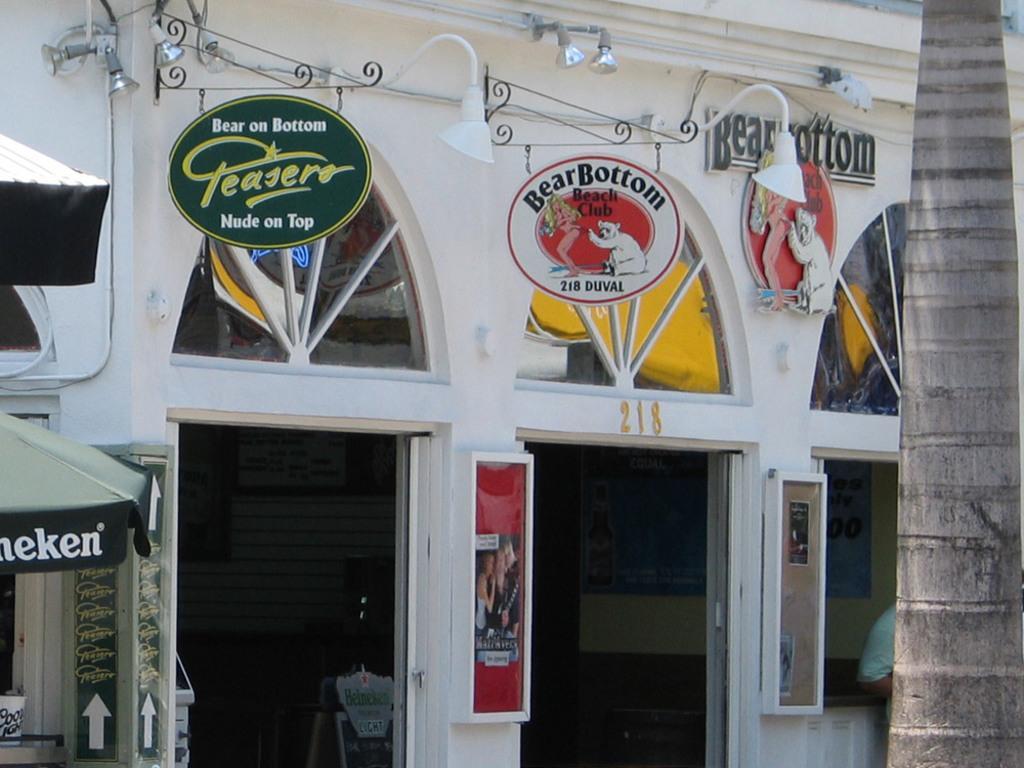In one or two sentences, can you explain what this image depicts? This image consists of a building in white color. On which there are boards. To the right, there is a tree. To the left, there is a small tent. 